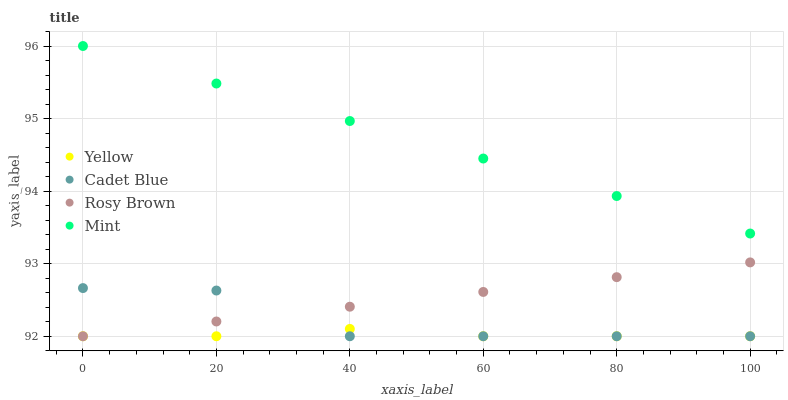Does Yellow have the minimum area under the curve?
Answer yes or no. Yes. Does Mint have the maximum area under the curve?
Answer yes or no. Yes. Does Cadet Blue have the minimum area under the curve?
Answer yes or no. No. Does Cadet Blue have the maximum area under the curve?
Answer yes or no. No. Is Mint the smoothest?
Answer yes or no. Yes. Is Cadet Blue the roughest?
Answer yes or no. Yes. Is Cadet Blue the smoothest?
Answer yes or no. No. Is Mint the roughest?
Answer yes or no. No. Does Rosy Brown have the lowest value?
Answer yes or no. Yes. Does Mint have the lowest value?
Answer yes or no. No. Does Mint have the highest value?
Answer yes or no. Yes. Does Cadet Blue have the highest value?
Answer yes or no. No. Is Rosy Brown less than Mint?
Answer yes or no. Yes. Is Mint greater than Rosy Brown?
Answer yes or no. Yes. Does Cadet Blue intersect Rosy Brown?
Answer yes or no. Yes. Is Cadet Blue less than Rosy Brown?
Answer yes or no. No. Is Cadet Blue greater than Rosy Brown?
Answer yes or no. No. Does Rosy Brown intersect Mint?
Answer yes or no. No. 